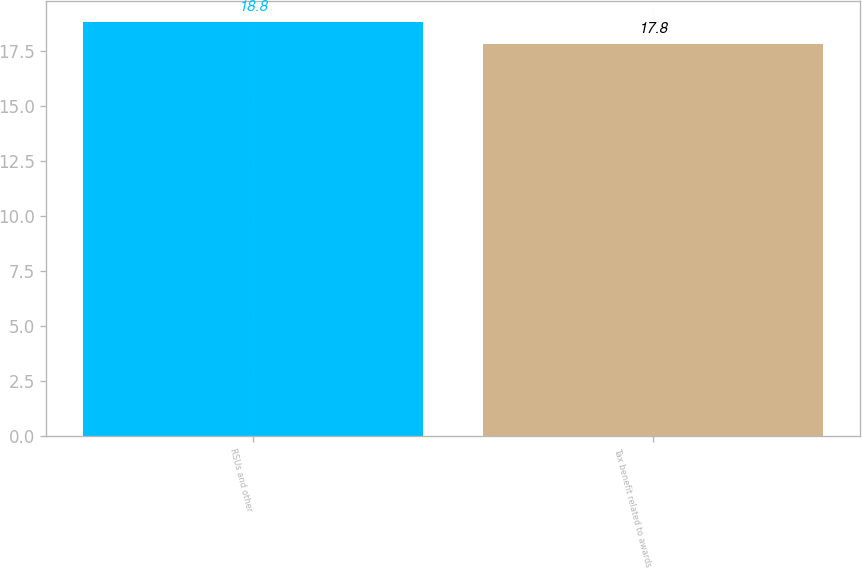<chart> <loc_0><loc_0><loc_500><loc_500><bar_chart><fcel>RSUs and other<fcel>Tax benefit related to awards<nl><fcel>18.8<fcel>17.8<nl></chart> 